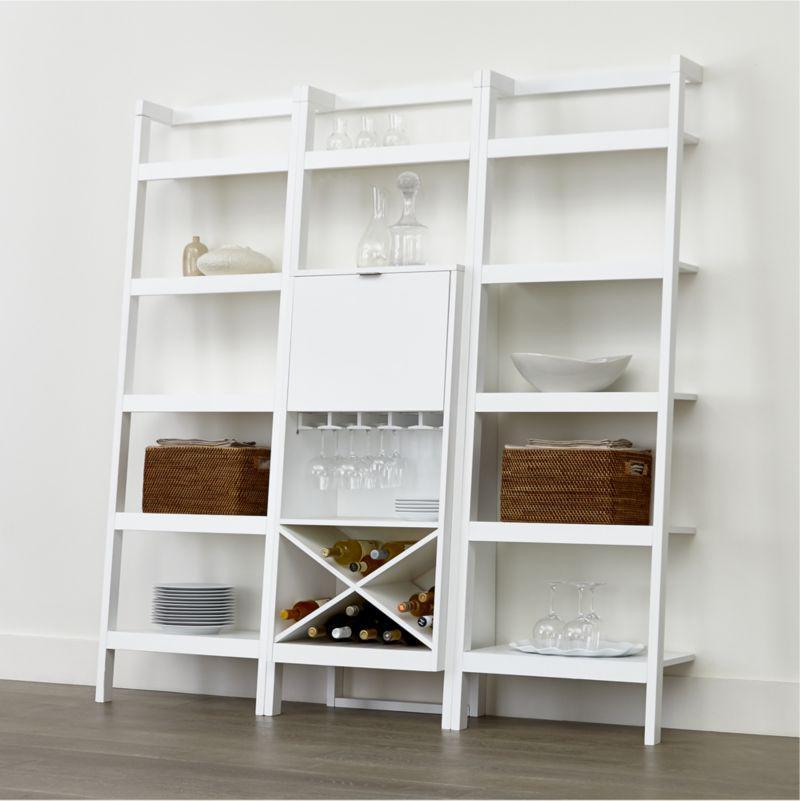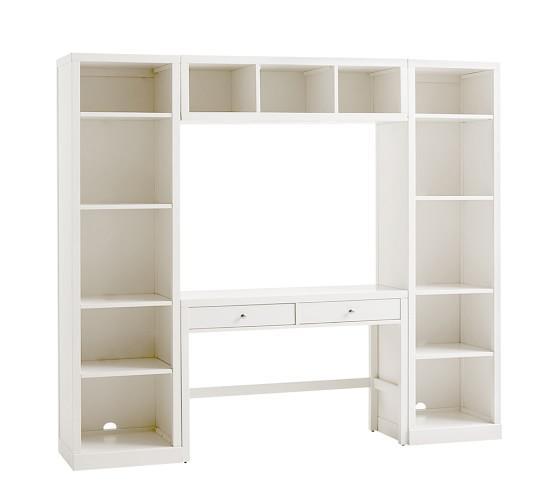The first image is the image on the left, the second image is the image on the right. Examine the images to the left and right. Is the description "There us a white bookshelf with a laptop on it ,  a stack of books with a bowl on top of another stack of books are on the shelf above the laptop" accurate? Answer yes or no. No. The first image is the image on the left, the second image is the image on the right. Assess this claim about the two images: "In one image, a bookshelf has three vertical shelf sections with a computer placed in the center unit.". Correct or not? Answer yes or no. No. 